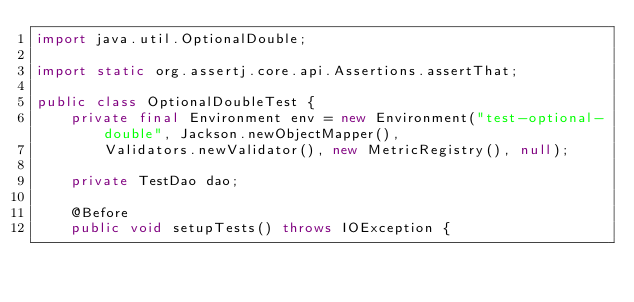Convert code to text. <code><loc_0><loc_0><loc_500><loc_500><_Java_>import java.util.OptionalDouble;

import static org.assertj.core.api.Assertions.assertThat;

public class OptionalDoubleTest {
    private final Environment env = new Environment("test-optional-double", Jackson.newObjectMapper(),
        Validators.newValidator(), new MetricRegistry(), null);

    private TestDao dao;

    @Before
    public void setupTests() throws IOException {</code> 